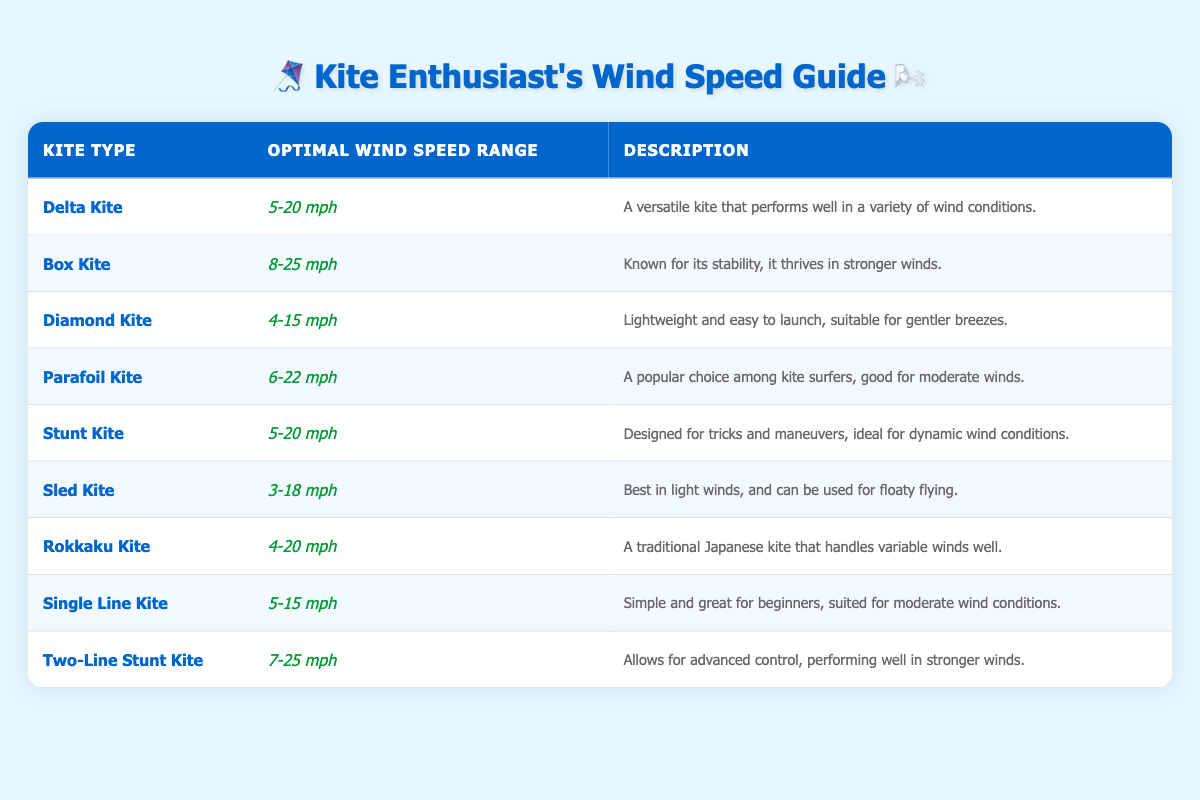What is the optimal wind speed range for a Delta Kite? The table directly lists the optimal wind speed range for a Delta Kite as "5-20 mph", located in the corresponding row.
Answer: 5-20 mph Which kite type has the highest upper limit for its optimal wind speed range? By scanning the table, the Box Kite has the highest upper limit at 25 mph, which can be determined by comparing the ranges provided for all kite types.
Answer: Box Kite Is a Diamond Kite suitable for wind speeds of 3 mph? Checking the optimal wind speed range for a Diamond Kite, it is "4-15 mph". Since 3 mph is lower than 4 mph, the answer is no.
Answer: No How many kites have an optimal wind speed range starting at 5 mph? The kites meeting this criterion are Delta Kite, Stunt Kite, Single Line Kite, and Two-Line Stunt Kite. There are a total of 4 kites that start at 5 mph when counting the rows that meet this condition.
Answer: 4 What is the median optimal wind speed upper limit among the kites listed? The upper limits for the kites are: 20, 25, 15, 22, 20, 18, 20, 15, and 25 mph. Arranging these values in order, we have: 15, 15, 18, 20, 20, 20, 22, 25, 25. There are 9 values, so the median is the 5th one, which is 20 mph.
Answer: 20 mph Which kite types are best for moderate wind conditions (between 10-20 mph)? By reviewing the kites that fit this range, we find that the Delta Kite, Stunt Kite, Rokkaku Kite, and Parafoil Kite have optimal wind conditions that fall within this range. Thus, there are 4 kite types suitable for moderate conditions between 10-20 mph.
Answer: 4 Does a Sled Kite work best in wind speeds higher than 20 mph? The optimal wind speed range for a Sled Kite is "3-18 mph", which specifically indicates that it does not accommodate winds higher than 20 mph. Thus, the answer is no.
Answer: No How many kites are suitable for wind speeds below 5 mph? Looking at the table, there are only kites with lower limits of 3 mph (Sled Kite), 4 mph (Diamond and Rokkaku Kites), and 5 mph (Delta and Stunt Kites). However, none of these kites are suitable for wind speeds lower than 3 mph, thus the answer is 0 kites for below 5 mph.
Answer: 0 